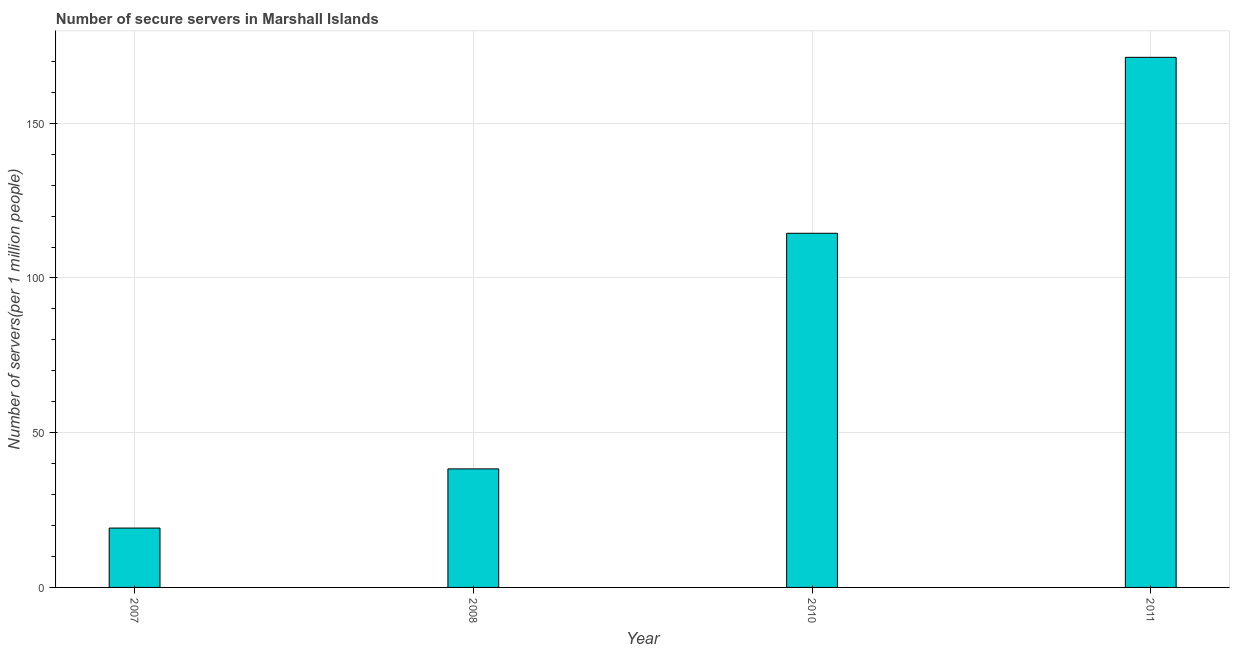Does the graph contain grids?
Provide a succinct answer. Yes. What is the title of the graph?
Offer a very short reply. Number of secure servers in Marshall Islands. What is the label or title of the Y-axis?
Give a very brief answer. Number of servers(per 1 million people). What is the number of secure internet servers in 2010?
Your response must be concise. 114.44. Across all years, what is the maximum number of secure internet servers?
Keep it short and to the point. 171.29. Across all years, what is the minimum number of secure internet servers?
Provide a short and direct response. 19.18. In which year was the number of secure internet servers minimum?
Make the answer very short. 2007. What is the sum of the number of secure internet servers?
Give a very brief answer. 343.22. What is the difference between the number of secure internet servers in 2008 and 2010?
Provide a succinct answer. -76.14. What is the average number of secure internet servers per year?
Your answer should be compact. 85.8. What is the median number of secure internet servers?
Offer a very short reply. 76.37. In how many years, is the number of secure internet servers greater than 150 ?
Offer a terse response. 1. What is the ratio of the number of secure internet servers in 2010 to that in 2011?
Keep it short and to the point. 0.67. What is the difference between the highest and the second highest number of secure internet servers?
Keep it short and to the point. 56.85. Is the sum of the number of secure internet servers in 2007 and 2011 greater than the maximum number of secure internet servers across all years?
Offer a terse response. Yes. What is the difference between the highest and the lowest number of secure internet servers?
Make the answer very short. 152.11. In how many years, is the number of secure internet servers greater than the average number of secure internet servers taken over all years?
Offer a very short reply. 2. How many years are there in the graph?
Offer a terse response. 4. What is the Number of servers(per 1 million people) in 2007?
Ensure brevity in your answer.  19.18. What is the Number of servers(per 1 million people) of 2008?
Offer a terse response. 38.3. What is the Number of servers(per 1 million people) in 2010?
Keep it short and to the point. 114.44. What is the Number of servers(per 1 million people) of 2011?
Your answer should be compact. 171.29. What is the difference between the Number of servers(per 1 million people) in 2007 and 2008?
Keep it short and to the point. -19.12. What is the difference between the Number of servers(per 1 million people) in 2007 and 2010?
Your answer should be very brief. -95.26. What is the difference between the Number of servers(per 1 million people) in 2007 and 2011?
Your answer should be compact. -152.11. What is the difference between the Number of servers(per 1 million people) in 2008 and 2010?
Your answer should be very brief. -76.14. What is the difference between the Number of servers(per 1 million people) in 2008 and 2011?
Your answer should be very brief. -133. What is the difference between the Number of servers(per 1 million people) in 2010 and 2011?
Ensure brevity in your answer.  -56.85. What is the ratio of the Number of servers(per 1 million people) in 2007 to that in 2008?
Your answer should be compact. 0.5. What is the ratio of the Number of servers(per 1 million people) in 2007 to that in 2010?
Provide a short and direct response. 0.17. What is the ratio of the Number of servers(per 1 million people) in 2007 to that in 2011?
Ensure brevity in your answer.  0.11. What is the ratio of the Number of servers(per 1 million people) in 2008 to that in 2010?
Ensure brevity in your answer.  0.34. What is the ratio of the Number of servers(per 1 million people) in 2008 to that in 2011?
Provide a succinct answer. 0.22. What is the ratio of the Number of servers(per 1 million people) in 2010 to that in 2011?
Offer a very short reply. 0.67. 